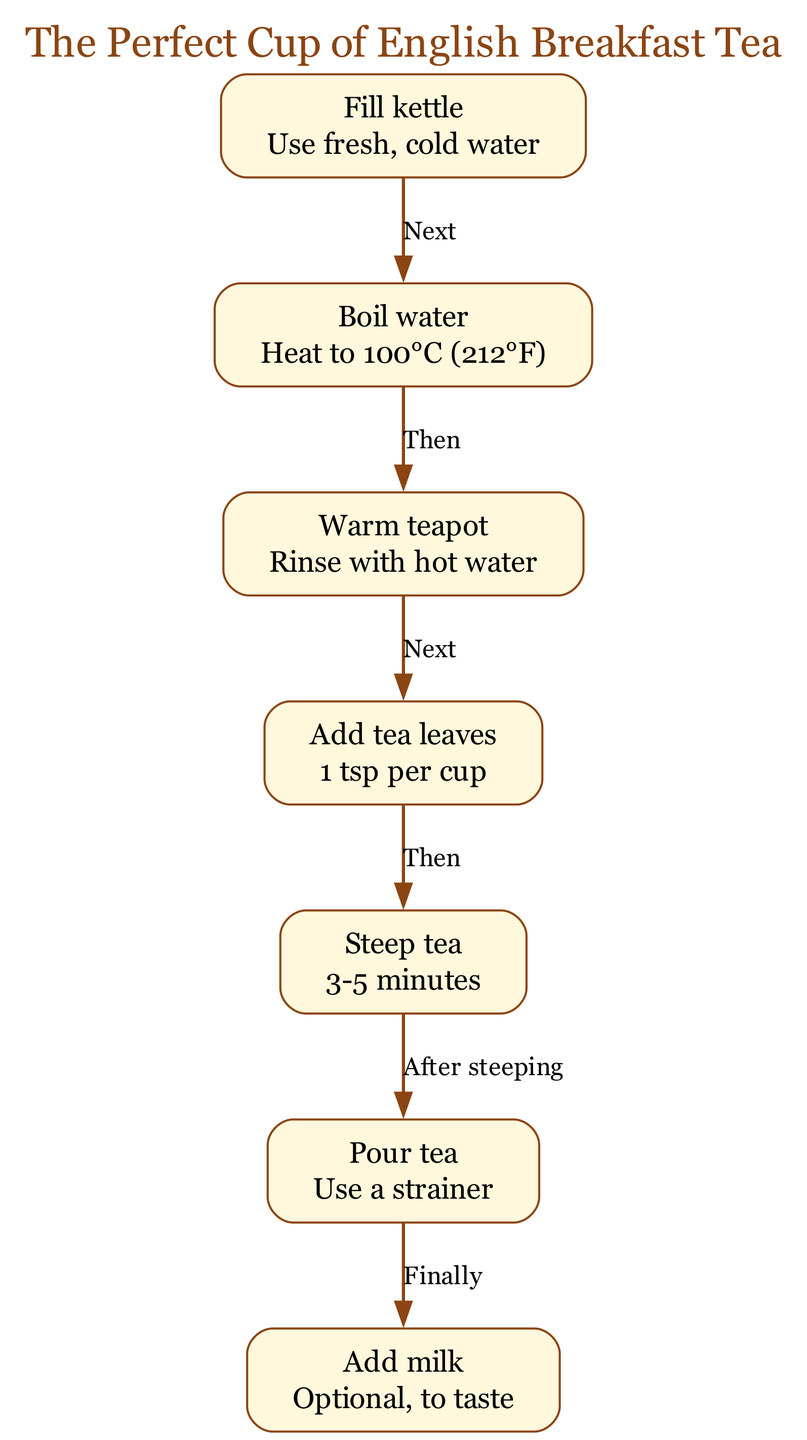What is the first step in brewing tea? The first step is to fill the kettle with fresh, cold water. This is identified as "Fill kettle" in the diagram, which is the starting node in the sequence.
Answer: Fill kettle How many total nodes are in the diagram? To determine the total number of nodes, we can count each step listed in the diagram. There are seven unique steps or nodes in the process.
Answer: Seven What temperature should the water be boiled to? The diagram specifies that the water needs to be boiled to 100°C (212°F) as indicated in the "Boil water" step.
Answer: 100°C (212°F) What do you do after adding tea leaves? According to the diagram, after adding tea leaves, the next step is to steep the tea for 3-5 minutes, which follows the "Add tea leaves" node.
Answer: Steep tea What is the optional ingredient you can add at the end? The diagram illustrates that the optional ingredient to be added at the end is milk, as shown in the "Add milk" step.
Answer: Milk Which step comes after pouring the tea? The step that follows "Pour tea" is "Add milk." This is shown in the diagram as the final step in the brewing process.
Answer: Add milk How long should the tea be steeped? The diagram indicates that the tea should be steeped for 3-5 minutes, which is detailed in the "Steep tea" step.
Answer: 3-5 minutes In the sequence from kettle to cup, which node represents warming the teapot? In the diagram, the node that represents warming the teapot is "Warm teapot," which is the step that comes after boiling the water.
Answer: Warm teapot What step requires a strainer? The diagram specifies that a strainer should be used during the "Pour tea" step, meaning it is essential to filter the tea when transferring it to the cup.
Answer: Pour tea 